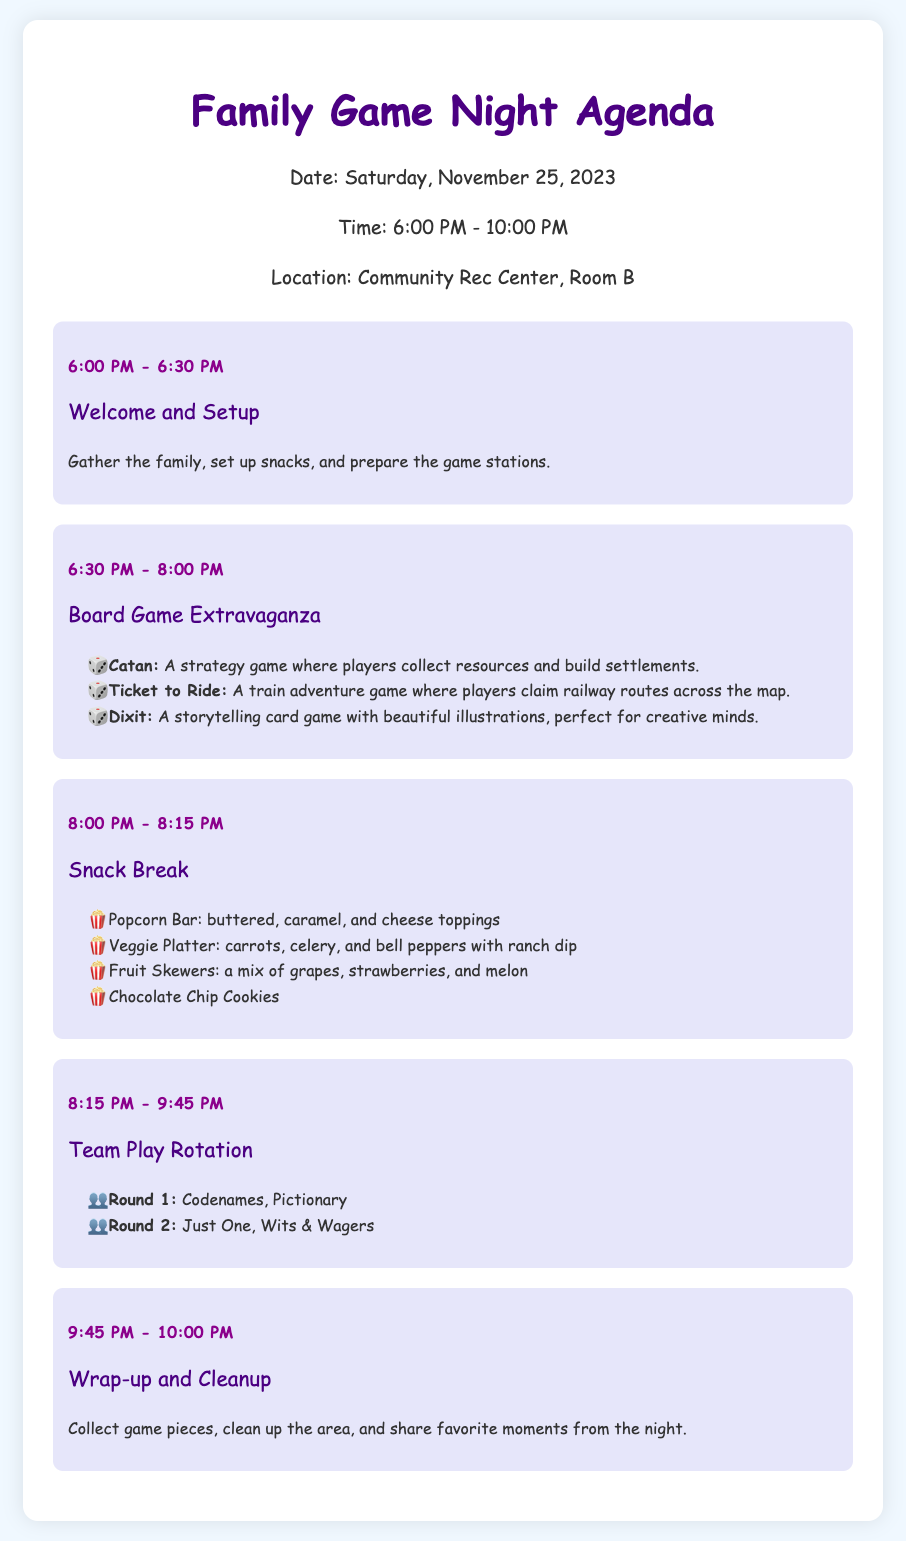What is the date of the game night? The date of the game night is provided in the header info of the document.
Answer: Saturday, November 25, 2023 What is the first activity listed in the agenda? The first activity in the agenda is mentioned with its time slot.
Answer: Welcome and Setup How long is the Snack Break scheduled for? The duration of the Snack Break is indicated in the time slot of that particular activity.
Answer: 15 minutes Which game is mentioned as part of the Team Play Rotation Round 2? The document lists specific games played in Round 2 of the Team Play Rotation.
Answer: Just One What snacks are available during the Snack Break? The document specifically lists the snacks served during the Snack Break.
Answer: Popcorn Bar, Veggie Platter, Fruit Skewers, Chocolate Chip Cookies How many main game sections are there in the agenda? The agenda has two main game sections before the Snack Break and the Team Play Rotation.
Answer: Two 